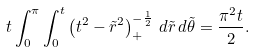Convert formula to latex. <formula><loc_0><loc_0><loc_500><loc_500>t \int _ { 0 } ^ { \pi } \int _ { 0 } ^ { t } \left ( t ^ { 2 } - \tilde { r } ^ { 2 } \right ) ^ { - \frac { 1 } { 2 } } _ { + } \, d \tilde { r } \, d \tilde { \theta } = \frac { \pi ^ { 2 } t } { 2 } .</formula> 